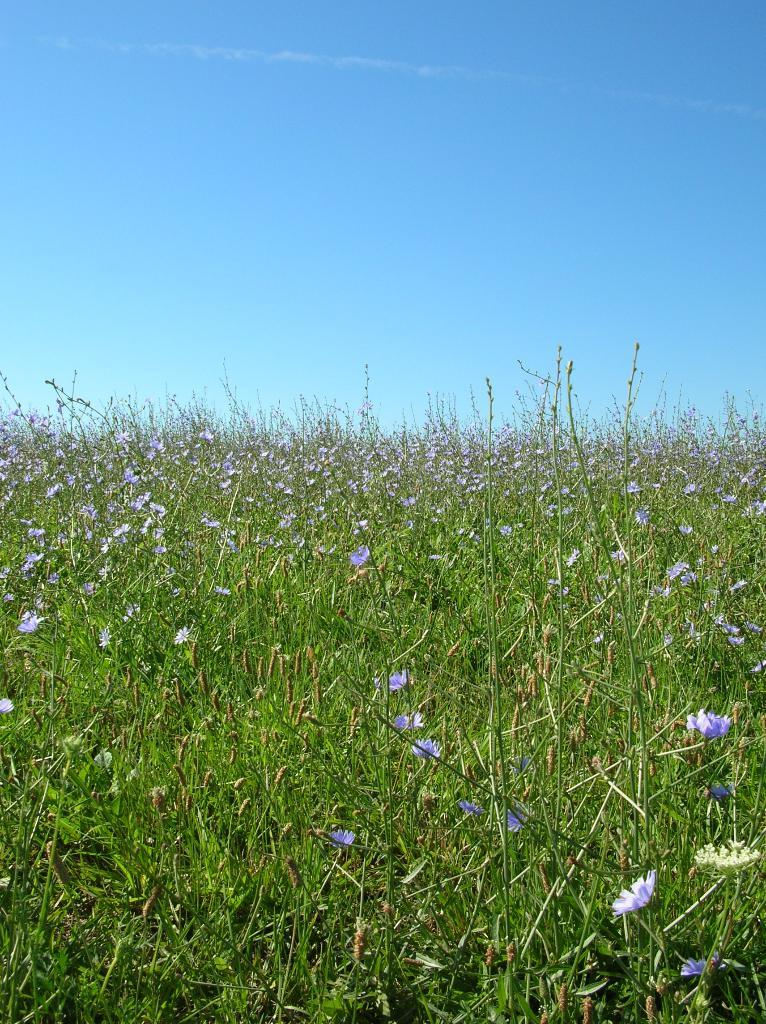What types of living organisms can be seen in the image? Plants and flowers are visible in the image. What can be seen in the sky in the image? The sky is visible in the image, and its color is blue. What type of answer can be heard from the acoustics in the image? There are no acoustics present in the image, and therefore no answers can be heard. 